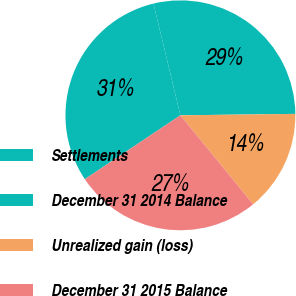<chart> <loc_0><loc_0><loc_500><loc_500><pie_chart><fcel>Settlements<fcel>December 31 2014 Balance<fcel>Unrealized gain (loss)<fcel>December 31 2015 Balance<nl><fcel>30.61%<fcel>28.57%<fcel>14.29%<fcel>26.53%<nl></chart> 